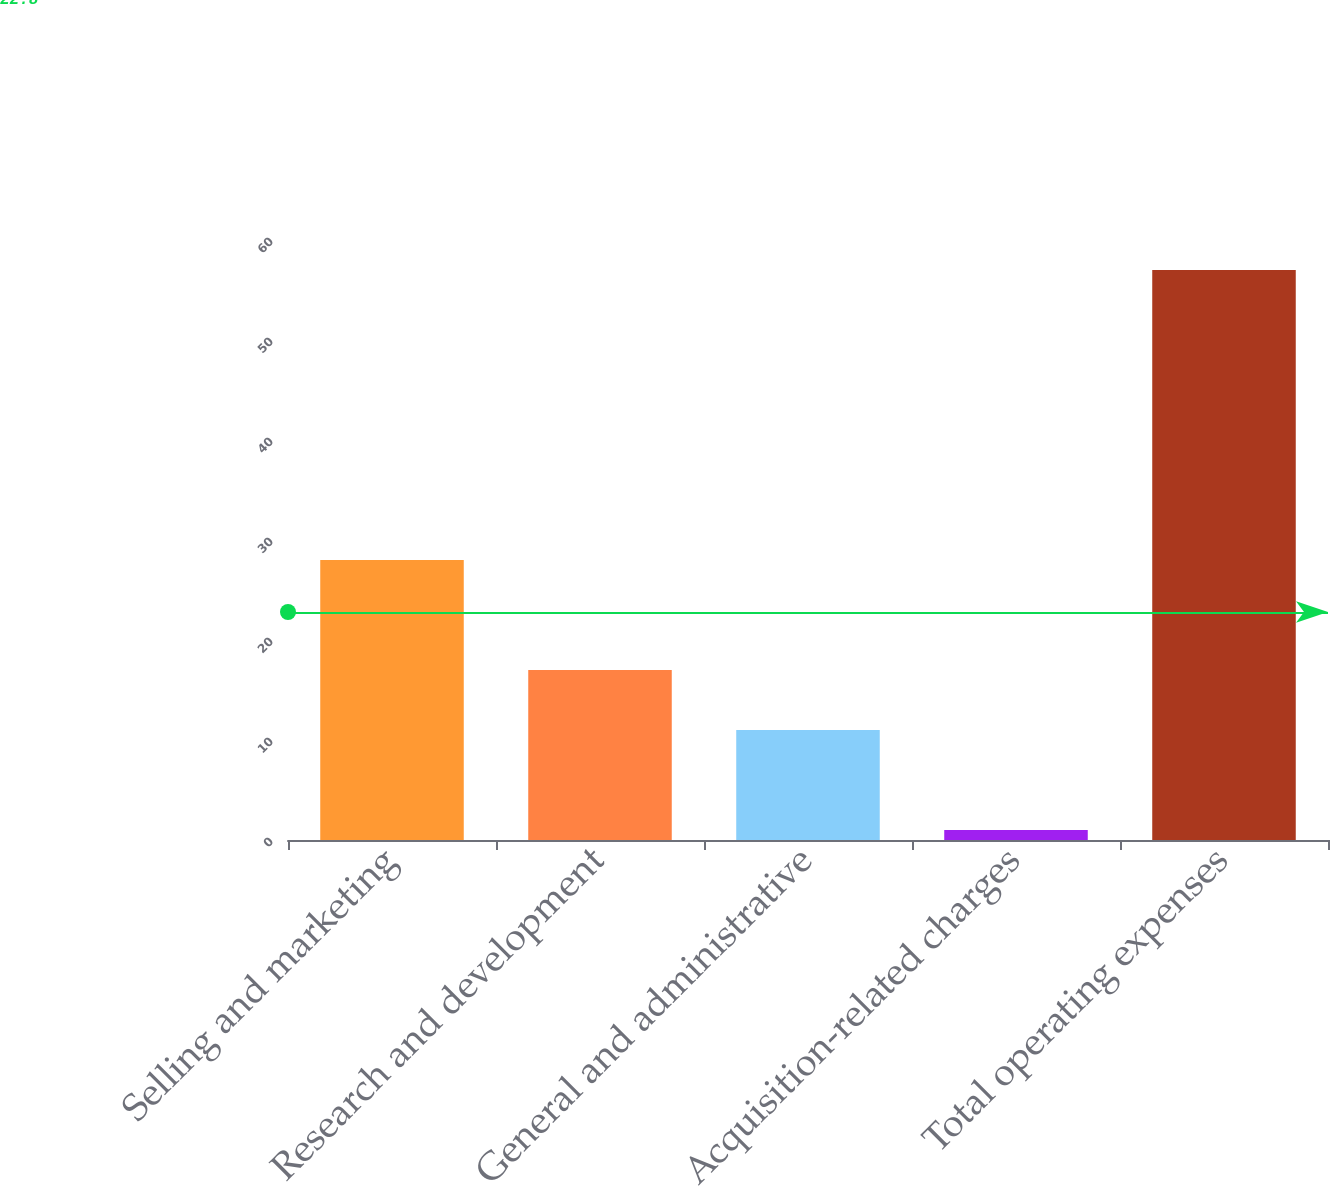<chart> <loc_0><loc_0><loc_500><loc_500><bar_chart><fcel>Selling and marketing<fcel>Research and development<fcel>General and administrative<fcel>Acquisition-related charges<fcel>Total operating expenses<nl><fcel>28<fcel>17<fcel>11<fcel>1<fcel>57<nl></chart> 